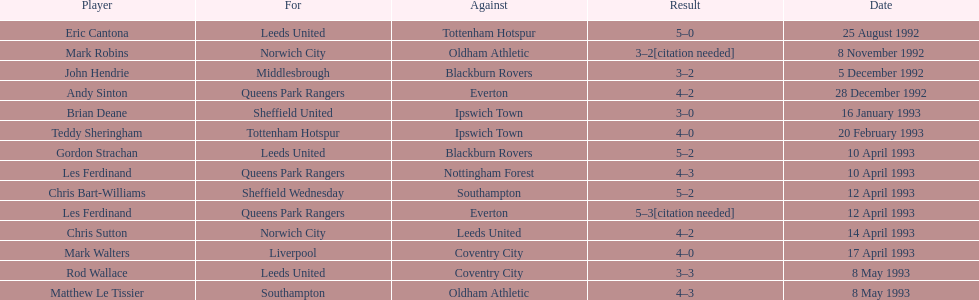Would you mind parsing the complete table? {'header': ['Player', 'For', 'Against', 'Result', 'Date'], 'rows': [['Eric Cantona', 'Leeds United', 'Tottenham Hotspur', '5–0', '25 August 1992'], ['Mark Robins', 'Norwich City', 'Oldham Athletic', '3–2[citation needed]', '8 November 1992'], ['John Hendrie', 'Middlesbrough', 'Blackburn Rovers', '3–2', '5 December 1992'], ['Andy Sinton', 'Queens Park Rangers', 'Everton', '4–2', '28 December 1992'], ['Brian Deane', 'Sheffield United', 'Ipswich Town', '3–0', '16 January 1993'], ['Teddy Sheringham', 'Tottenham Hotspur', 'Ipswich Town', '4–0', '20 February 1993'], ['Gordon Strachan', 'Leeds United', 'Blackburn Rovers', '5–2', '10 April 1993'], ['Les Ferdinand', 'Queens Park Rangers', 'Nottingham Forest', '4–3', '10 April 1993'], ['Chris Bart-Williams', 'Sheffield Wednesday', 'Southampton', '5–2', '12 April 1993'], ['Les Ferdinand', 'Queens Park Rangers', 'Everton', '5–3[citation needed]', '12 April 1993'], ['Chris Sutton', 'Norwich City', 'Leeds United', '4–2', '14 April 1993'], ['Mark Walters', 'Liverpool', 'Coventry City', '4–0', '17 April 1993'], ['Rod Wallace', 'Leeds United', 'Coventry City', '3–3', '8 May 1993'], ['Matthew Le Tissier', 'Southampton', 'Oldham Athletic', '4–3', '8 May 1993']]} Name the players for tottenham hotspur. Teddy Sheringham. 